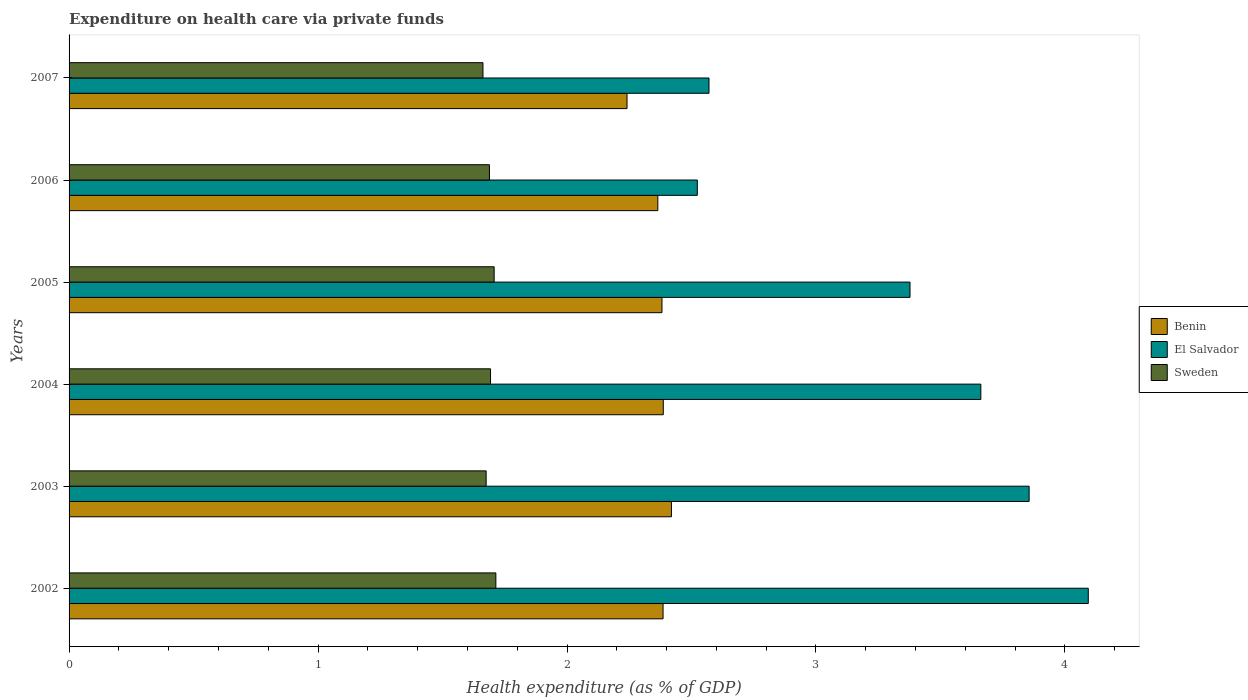How many different coloured bars are there?
Your answer should be very brief. 3. How many groups of bars are there?
Ensure brevity in your answer.  6. Are the number of bars per tick equal to the number of legend labels?
Your response must be concise. Yes. How many bars are there on the 4th tick from the top?
Your answer should be compact. 3. In how many cases, is the number of bars for a given year not equal to the number of legend labels?
Offer a terse response. 0. What is the expenditure made on health care in Sweden in 2005?
Your answer should be very brief. 1.71. Across all years, what is the maximum expenditure made on health care in Sweden?
Offer a very short reply. 1.71. Across all years, what is the minimum expenditure made on health care in Sweden?
Provide a succinct answer. 1.66. What is the total expenditure made on health care in Benin in the graph?
Your answer should be compact. 14.18. What is the difference between the expenditure made on health care in Sweden in 2004 and that in 2006?
Provide a succinct answer. 0. What is the difference between the expenditure made on health care in Benin in 2004 and the expenditure made on health care in Sweden in 2007?
Provide a short and direct response. 0.72. What is the average expenditure made on health care in El Salvador per year?
Make the answer very short. 3.35. In the year 2004, what is the difference between the expenditure made on health care in El Salvador and expenditure made on health care in Benin?
Your answer should be very brief. 1.28. What is the ratio of the expenditure made on health care in Sweden in 2003 to that in 2005?
Make the answer very short. 0.98. Is the difference between the expenditure made on health care in El Salvador in 2006 and 2007 greater than the difference between the expenditure made on health care in Benin in 2006 and 2007?
Keep it short and to the point. No. What is the difference between the highest and the second highest expenditure made on health care in Benin?
Provide a succinct answer. 0.03. What is the difference between the highest and the lowest expenditure made on health care in Sweden?
Your answer should be compact. 0.05. In how many years, is the expenditure made on health care in Benin greater than the average expenditure made on health care in Benin taken over all years?
Give a very brief answer. 5. Is the sum of the expenditure made on health care in Benin in 2002 and 2003 greater than the maximum expenditure made on health care in El Salvador across all years?
Offer a very short reply. Yes. What does the 2nd bar from the top in 2003 represents?
Your answer should be compact. El Salvador. What does the 2nd bar from the bottom in 2005 represents?
Provide a succinct answer. El Salvador. Is it the case that in every year, the sum of the expenditure made on health care in Benin and expenditure made on health care in El Salvador is greater than the expenditure made on health care in Sweden?
Give a very brief answer. Yes. Are the values on the major ticks of X-axis written in scientific E-notation?
Ensure brevity in your answer.  No. Does the graph contain any zero values?
Your answer should be compact. No. What is the title of the graph?
Provide a succinct answer. Expenditure on health care via private funds. Does "Fiji" appear as one of the legend labels in the graph?
Give a very brief answer. No. What is the label or title of the X-axis?
Offer a terse response. Health expenditure (as % of GDP). What is the label or title of the Y-axis?
Your answer should be very brief. Years. What is the Health expenditure (as % of GDP) of Benin in 2002?
Give a very brief answer. 2.39. What is the Health expenditure (as % of GDP) in El Salvador in 2002?
Offer a terse response. 4.09. What is the Health expenditure (as % of GDP) in Sweden in 2002?
Provide a short and direct response. 1.71. What is the Health expenditure (as % of GDP) in Benin in 2003?
Give a very brief answer. 2.42. What is the Health expenditure (as % of GDP) of El Salvador in 2003?
Your answer should be very brief. 3.86. What is the Health expenditure (as % of GDP) in Sweden in 2003?
Give a very brief answer. 1.68. What is the Health expenditure (as % of GDP) in Benin in 2004?
Ensure brevity in your answer.  2.39. What is the Health expenditure (as % of GDP) in El Salvador in 2004?
Your answer should be very brief. 3.66. What is the Health expenditure (as % of GDP) of Sweden in 2004?
Make the answer very short. 1.69. What is the Health expenditure (as % of GDP) of Benin in 2005?
Your response must be concise. 2.38. What is the Health expenditure (as % of GDP) in El Salvador in 2005?
Give a very brief answer. 3.38. What is the Health expenditure (as % of GDP) in Sweden in 2005?
Your answer should be very brief. 1.71. What is the Health expenditure (as % of GDP) in Benin in 2006?
Keep it short and to the point. 2.36. What is the Health expenditure (as % of GDP) of El Salvador in 2006?
Give a very brief answer. 2.52. What is the Health expenditure (as % of GDP) in Sweden in 2006?
Offer a very short reply. 1.69. What is the Health expenditure (as % of GDP) in Benin in 2007?
Your answer should be very brief. 2.24. What is the Health expenditure (as % of GDP) in El Salvador in 2007?
Offer a very short reply. 2.57. What is the Health expenditure (as % of GDP) of Sweden in 2007?
Your answer should be compact. 1.66. Across all years, what is the maximum Health expenditure (as % of GDP) in Benin?
Your answer should be compact. 2.42. Across all years, what is the maximum Health expenditure (as % of GDP) of El Salvador?
Offer a terse response. 4.09. Across all years, what is the maximum Health expenditure (as % of GDP) in Sweden?
Your answer should be very brief. 1.71. Across all years, what is the minimum Health expenditure (as % of GDP) of Benin?
Provide a succinct answer. 2.24. Across all years, what is the minimum Health expenditure (as % of GDP) in El Salvador?
Ensure brevity in your answer.  2.52. Across all years, what is the minimum Health expenditure (as % of GDP) of Sweden?
Give a very brief answer. 1.66. What is the total Health expenditure (as % of GDP) in Benin in the graph?
Ensure brevity in your answer.  14.18. What is the total Health expenditure (as % of GDP) in El Salvador in the graph?
Give a very brief answer. 20.08. What is the total Health expenditure (as % of GDP) in Sweden in the graph?
Offer a very short reply. 10.14. What is the difference between the Health expenditure (as % of GDP) of Benin in 2002 and that in 2003?
Offer a terse response. -0.03. What is the difference between the Health expenditure (as % of GDP) of El Salvador in 2002 and that in 2003?
Provide a succinct answer. 0.24. What is the difference between the Health expenditure (as % of GDP) in Sweden in 2002 and that in 2003?
Give a very brief answer. 0.04. What is the difference between the Health expenditure (as % of GDP) in Benin in 2002 and that in 2004?
Make the answer very short. -0. What is the difference between the Health expenditure (as % of GDP) in El Salvador in 2002 and that in 2004?
Provide a succinct answer. 0.43. What is the difference between the Health expenditure (as % of GDP) in Sweden in 2002 and that in 2004?
Provide a short and direct response. 0.02. What is the difference between the Health expenditure (as % of GDP) in Benin in 2002 and that in 2005?
Provide a short and direct response. 0. What is the difference between the Health expenditure (as % of GDP) in El Salvador in 2002 and that in 2005?
Make the answer very short. 0.72. What is the difference between the Health expenditure (as % of GDP) of Sweden in 2002 and that in 2005?
Make the answer very short. 0.01. What is the difference between the Health expenditure (as % of GDP) in Benin in 2002 and that in 2006?
Keep it short and to the point. 0.02. What is the difference between the Health expenditure (as % of GDP) in El Salvador in 2002 and that in 2006?
Your answer should be very brief. 1.57. What is the difference between the Health expenditure (as % of GDP) of Sweden in 2002 and that in 2006?
Make the answer very short. 0.03. What is the difference between the Health expenditure (as % of GDP) of Benin in 2002 and that in 2007?
Make the answer very short. 0.14. What is the difference between the Health expenditure (as % of GDP) of El Salvador in 2002 and that in 2007?
Offer a very short reply. 1.52. What is the difference between the Health expenditure (as % of GDP) of Sweden in 2002 and that in 2007?
Your answer should be compact. 0.05. What is the difference between the Health expenditure (as % of GDP) of Benin in 2003 and that in 2004?
Your response must be concise. 0.03. What is the difference between the Health expenditure (as % of GDP) of El Salvador in 2003 and that in 2004?
Ensure brevity in your answer.  0.19. What is the difference between the Health expenditure (as % of GDP) of Sweden in 2003 and that in 2004?
Give a very brief answer. -0.02. What is the difference between the Health expenditure (as % of GDP) in Benin in 2003 and that in 2005?
Keep it short and to the point. 0.04. What is the difference between the Health expenditure (as % of GDP) of El Salvador in 2003 and that in 2005?
Offer a very short reply. 0.48. What is the difference between the Health expenditure (as % of GDP) of Sweden in 2003 and that in 2005?
Ensure brevity in your answer.  -0.03. What is the difference between the Health expenditure (as % of GDP) in Benin in 2003 and that in 2006?
Offer a terse response. 0.05. What is the difference between the Health expenditure (as % of GDP) of El Salvador in 2003 and that in 2006?
Your answer should be compact. 1.33. What is the difference between the Health expenditure (as % of GDP) of Sweden in 2003 and that in 2006?
Provide a short and direct response. -0.01. What is the difference between the Health expenditure (as % of GDP) of Benin in 2003 and that in 2007?
Provide a succinct answer. 0.18. What is the difference between the Health expenditure (as % of GDP) of El Salvador in 2003 and that in 2007?
Give a very brief answer. 1.29. What is the difference between the Health expenditure (as % of GDP) in Sweden in 2003 and that in 2007?
Ensure brevity in your answer.  0.01. What is the difference between the Health expenditure (as % of GDP) in Benin in 2004 and that in 2005?
Provide a succinct answer. 0.01. What is the difference between the Health expenditure (as % of GDP) in El Salvador in 2004 and that in 2005?
Ensure brevity in your answer.  0.28. What is the difference between the Health expenditure (as % of GDP) in Sweden in 2004 and that in 2005?
Ensure brevity in your answer.  -0.01. What is the difference between the Health expenditure (as % of GDP) in Benin in 2004 and that in 2006?
Ensure brevity in your answer.  0.02. What is the difference between the Health expenditure (as % of GDP) in El Salvador in 2004 and that in 2006?
Provide a short and direct response. 1.14. What is the difference between the Health expenditure (as % of GDP) in Sweden in 2004 and that in 2006?
Provide a succinct answer. 0. What is the difference between the Health expenditure (as % of GDP) of Benin in 2004 and that in 2007?
Ensure brevity in your answer.  0.15. What is the difference between the Health expenditure (as % of GDP) in El Salvador in 2004 and that in 2007?
Your response must be concise. 1.09. What is the difference between the Health expenditure (as % of GDP) in Sweden in 2004 and that in 2007?
Ensure brevity in your answer.  0.03. What is the difference between the Health expenditure (as % of GDP) of Benin in 2005 and that in 2006?
Provide a succinct answer. 0.02. What is the difference between the Health expenditure (as % of GDP) of El Salvador in 2005 and that in 2006?
Provide a short and direct response. 0.85. What is the difference between the Health expenditure (as % of GDP) of Sweden in 2005 and that in 2006?
Ensure brevity in your answer.  0.02. What is the difference between the Health expenditure (as % of GDP) in Benin in 2005 and that in 2007?
Provide a short and direct response. 0.14. What is the difference between the Health expenditure (as % of GDP) in El Salvador in 2005 and that in 2007?
Your response must be concise. 0.81. What is the difference between the Health expenditure (as % of GDP) of Sweden in 2005 and that in 2007?
Provide a succinct answer. 0.04. What is the difference between the Health expenditure (as % of GDP) of Benin in 2006 and that in 2007?
Provide a short and direct response. 0.12. What is the difference between the Health expenditure (as % of GDP) of El Salvador in 2006 and that in 2007?
Ensure brevity in your answer.  -0.05. What is the difference between the Health expenditure (as % of GDP) in Sweden in 2006 and that in 2007?
Offer a very short reply. 0.03. What is the difference between the Health expenditure (as % of GDP) of Benin in 2002 and the Health expenditure (as % of GDP) of El Salvador in 2003?
Your answer should be very brief. -1.47. What is the difference between the Health expenditure (as % of GDP) in Benin in 2002 and the Health expenditure (as % of GDP) in Sweden in 2003?
Your response must be concise. 0.71. What is the difference between the Health expenditure (as % of GDP) of El Salvador in 2002 and the Health expenditure (as % of GDP) of Sweden in 2003?
Your response must be concise. 2.42. What is the difference between the Health expenditure (as % of GDP) of Benin in 2002 and the Health expenditure (as % of GDP) of El Salvador in 2004?
Keep it short and to the point. -1.28. What is the difference between the Health expenditure (as % of GDP) of Benin in 2002 and the Health expenditure (as % of GDP) of Sweden in 2004?
Provide a succinct answer. 0.69. What is the difference between the Health expenditure (as % of GDP) in El Salvador in 2002 and the Health expenditure (as % of GDP) in Sweden in 2004?
Your response must be concise. 2.4. What is the difference between the Health expenditure (as % of GDP) in Benin in 2002 and the Health expenditure (as % of GDP) in El Salvador in 2005?
Make the answer very short. -0.99. What is the difference between the Health expenditure (as % of GDP) in Benin in 2002 and the Health expenditure (as % of GDP) in Sweden in 2005?
Your answer should be compact. 0.68. What is the difference between the Health expenditure (as % of GDP) of El Salvador in 2002 and the Health expenditure (as % of GDP) of Sweden in 2005?
Provide a short and direct response. 2.39. What is the difference between the Health expenditure (as % of GDP) of Benin in 2002 and the Health expenditure (as % of GDP) of El Salvador in 2006?
Ensure brevity in your answer.  -0.14. What is the difference between the Health expenditure (as % of GDP) in Benin in 2002 and the Health expenditure (as % of GDP) in Sweden in 2006?
Keep it short and to the point. 0.7. What is the difference between the Health expenditure (as % of GDP) of El Salvador in 2002 and the Health expenditure (as % of GDP) of Sweden in 2006?
Your answer should be very brief. 2.41. What is the difference between the Health expenditure (as % of GDP) of Benin in 2002 and the Health expenditure (as % of GDP) of El Salvador in 2007?
Provide a succinct answer. -0.18. What is the difference between the Health expenditure (as % of GDP) in Benin in 2002 and the Health expenditure (as % of GDP) in Sweden in 2007?
Provide a succinct answer. 0.72. What is the difference between the Health expenditure (as % of GDP) of El Salvador in 2002 and the Health expenditure (as % of GDP) of Sweden in 2007?
Offer a terse response. 2.43. What is the difference between the Health expenditure (as % of GDP) in Benin in 2003 and the Health expenditure (as % of GDP) in El Salvador in 2004?
Offer a terse response. -1.24. What is the difference between the Health expenditure (as % of GDP) in Benin in 2003 and the Health expenditure (as % of GDP) in Sweden in 2004?
Provide a short and direct response. 0.73. What is the difference between the Health expenditure (as % of GDP) of El Salvador in 2003 and the Health expenditure (as % of GDP) of Sweden in 2004?
Give a very brief answer. 2.16. What is the difference between the Health expenditure (as % of GDP) of Benin in 2003 and the Health expenditure (as % of GDP) of El Salvador in 2005?
Make the answer very short. -0.96. What is the difference between the Health expenditure (as % of GDP) of Benin in 2003 and the Health expenditure (as % of GDP) of Sweden in 2005?
Your answer should be compact. 0.71. What is the difference between the Health expenditure (as % of GDP) in El Salvador in 2003 and the Health expenditure (as % of GDP) in Sweden in 2005?
Give a very brief answer. 2.15. What is the difference between the Health expenditure (as % of GDP) of Benin in 2003 and the Health expenditure (as % of GDP) of El Salvador in 2006?
Your answer should be very brief. -0.1. What is the difference between the Health expenditure (as % of GDP) of Benin in 2003 and the Health expenditure (as % of GDP) of Sweden in 2006?
Your answer should be very brief. 0.73. What is the difference between the Health expenditure (as % of GDP) of El Salvador in 2003 and the Health expenditure (as % of GDP) of Sweden in 2006?
Give a very brief answer. 2.17. What is the difference between the Health expenditure (as % of GDP) in Benin in 2003 and the Health expenditure (as % of GDP) in El Salvador in 2007?
Ensure brevity in your answer.  -0.15. What is the difference between the Health expenditure (as % of GDP) in Benin in 2003 and the Health expenditure (as % of GDP) in Sweden in 2007?
Your answer should be very brief. 0.76. What is the difference between the Health expenditure (as % of GDP) of El Salvador in 2003 and the Health expenditure (as % of GDP) of Sweden in 2007?
Your response must be concise. 2.19. What is the difference between the Health expenditure (as % of GDP) in Benin in 2004 and the Health expenditure (as % of GDP) in El Salvador in 2005?
Offer a very short reply. -0.99. What is the difference between the Health expenditure (as % of GDP) in Benin in 2004 and the Health expenditure (as % of GDP) in Sweden in 2005?
Your answer should be very brief. 0.68. What is the difference between the Health expenditure (as % of GDP) in El Salvador in 2004 and the Health expenditure (as % of GDP) in Sweden in 2005?
Provide a short and direct response. 1.95. What is the difference between the Health expenditure (as % of GDP) in Benin in 2004 and the Health expenditure (as % of GDP) in El Salvador in 2006?
Your answer should be very brief. -0.14. What is the difference between the Health expenditure (as % of GDP) in Benin in 2004 and the Health expenditure (as % of GDP) in Sweden in 2006?
Your answer should be compact. 0.7. What is the difference between the Health expenditure (as % of GDP) in El Salvador in 2004 and the Health expenditure (as % of GDP) in Sweden in 2006?
Your answer should be very brief. 1.97. What is the difference between the Health expenditure (as % of GDP) in Benin in 2004 and the Health expenditure (as % of GDP) in El Salvador in 2007?
Your answer should be compact. -0.18. What is the difference between the Health expenditure (as % of GDP) of Benin in 2004 and the Health expenditure (as % of GDP) of Sweden in 2007?
Offer a very short reply. 0.72. What is the difference between the Health expenditure (as % of GDP) in El Salvador in 2004 and the Health expenditure (as % of GDP) in Sweden in 2007?
Your answer should be compact. 2. What is the difference between the Health expenditure (as % of GDP) in Benin in 2005 and the Health expenditure (as % of GDP) in El Salvador in 2006?
Provide a succinct answer. -0.14. What is the difference between the Health expenditure (as % of GDP) in Benin in 2005 and the Health expenditure (as % of GDP) in Sweden in 2006?
Your answer should be very brief. 0.69. What is the difference between the Health expenditure (as % of GDP) in El Salvador in 2005 and the Health expenditure (as % of GDP) in Sweden in 2006?
Your answer should be very brief. 1.69. What is the difference between the Health expenditure (as % of GDP) of Benin in 2005 and the Health expenditure (as % of GDP) of El Salvador in 2007?
Keep it short and to the point. -0.19. What is the difference between the Health expenditure (as % of GDP) of Benin in 2005 and the Health expenditure (as % of GDP) of Sweden in 2007?
Keep it short and to the point. 0.72. What is the difference between the Health expenditure (as % of GDP) in El Salvador in 2005 and the Health expenditure (as % of GDP) in Sweden in 2007?
Your answer should be compact. 1.72. What is the difference between the Health expenditure (as % of GDP) in Benin in 2006 and the Health expenditure (as % of GDP) in El Salvador in 2007?
Offer a terse response. -0.21. What is the difference between the Health expenditure (as % of GDP) in Benin in 2006 and the Health expenditure (as % of GDP) in Sweden in 2007?
Ensure brevity in your answer.  0.7. What is the difference between the Health expenditure (as % of GDP) in El Salvador in 2006 and the Health expenditure (as % of GDP) in Sweden in 2007?
Your response must be concise. 0.86. What is the average Health expenditure (as % of GDP) in Benin per year?
Give a very brief answer. 2.36. What is the average Health expenditure (as % of GDP) of El Salvador per year?
Provide a succinct answer. 3.35. What is the average Health expenditure (as % of GDP) of Sweden per year?
Keep it short and to the point. 1.69. In the year 2002, what is the difference between the Health expenditure (as % of GDP) of Benin and Health expenditure (as % of GDP) of El Salvador?
Your response must be concise. -1.71. In the year 2002, what is the difference between the Health expenditure (as % of GDP) of Benin and Health expenditure (as % of GDP) of Sweden?
Your answer should be compact. 0.67. In the year 2002, what is the difference between the Health expenditure (as % of GDP) of El Salvador and Health expenditure (as % of GDP) of Sweden?
Make the answer very short. 2.38. In the year 2003, what is the difference between the Health expenditure (as % of GDP) of Benin and Health expenditure (as % of GDP) of El Salvador?
Your response must be concise. -1.44. In the year 2003, what is the difference between the Health expenditure (as % of GDP) of Benin and Health expenditure (as % of GDP) of Sweden?
Give a very brief answer. 0.74. In the year 2003, what is the difference between the Health expenditure (as % of GDP) of El Salvador and Health expenditure (as % of GDP) of Sweden?
Make the answer very short. 2.18. In the year 2004, what is the difference between the Health expenditure (as % of GDP) of Benin and Health expenditure (as % of GDP) of El Salvador?
Give a very brief answer. -1.28. In the year 2004, what is the difference between the Health expenditure (as % of GDP) in Benin and Health expenditure (as % of GDP) in Sweden?
Give a very brief answer. 0.69. In the year 2004, what is the difference between the Health expenditure (as % of GDP) of El Salvador and Health expenditure (as % of GDP) of Sweden?
Make the answer very short. 1.97. In the year 2005, what is the difference between the Health expenditure (as % of GDP) of Benin and Health expenditure (as % of GDP) of El Salvador?
Ensure brevity in your answer.  -1. In the year 2005, what is the difference between the Health expenditure (as % of GDP) in Benin and Health expenditure (as % of GDP) in Sweden?
Provide a succinct answer. 0.67. In the year 2005, what is the difference between the Health expenditure (as % of GDP) in El Salvador and Health expenditure (as % of GDP) in Sweden?
Keep it short and to the point. 1.67. In the year 2006, what is the difference between the Health expenditure (as % of GDP) of Benin and Health expenditure (as % of GDP) of El Salvador?
Your answer should be very brief. -0.16. In the year 2006, what is the difference between the Health expenditure (as % of GDP) in Benin and Health expenditure (as % of GDP) in Sweden?
Offer a very short reply. 0.68. In the year 2006, what is the difference between the Health expenditure (as % of GDP) of El Salvador and Health expenditure (as % of GDP) of Sweden?
Offer a terse response. 0.83. In the year 2007, what is the difference between the Health expenditure (as % of GDP) of Benin and Health expenditure (as % of GDP) of El Salvador?
Provide a succinct answer. -0.33. In the year 2007, what is the difference between the Health expenditure (as % of GDP) in Benin and Health expenditure (as % of GDP) in Sweden?
Your answer should be very brief. 0.58. In the year 2007, what is the difference between the Health expenditure (as % of GDP) in El Salvador and Health expenditure (as % of GDP) in Sweden?
Offer a terse response. 0.91. What is the ratio of the Health expenditure (as % of GDP) of Benin in 2002 to that in 2003?
Provide a short and direct response. 0.99. What is the ratio of the Health expenditure (as % of GDP) of El Salvador in 2002 to that in 2003?
Offer a terse response. 1.06. What is the ratio of the Health expenditure (as % of GDP) in Sweden in 2002 to that in 2003?
Provide a short and direct response. 1.02. What is the ratio of the Health expenditure (as % of GDP) of Benin in 2002 to that in 2004?
Your response must be concise. 1. What is the ratio of the Health expenditure (as % of GDP) in El Salvador in 2002 to that in 2004?
Offer a very short reply. 1.12. What is the ratio of the Health expenditure (as % of GDP) in Sweden in 2002 to that in 2004?
Offer a very short reply. 1.01. What is the ratio of the Health expenditure (as % of GDP) of Benin in 2002 to that in 2005?
Keep it short and to the point. 1. What is the ratio of the Health expenditure (as % of GDP) of El Salvador in 2002 to that in 2005?
Provide a short and direct response. 1.21. What is the ratio of the Health expenditure (as % of GDP) in Sweden in 2002 to that in 2005?
Provide a short and direct response. 1. What is the ratio of the Health expenditure (as % of GDP) of Benin in 2002 to that in 2006?
Your answer should be very brief. 1.01. What is the ratio of the Health expenditure (as % of GDP) of El Salvador in 2002 to that in 2006?
Provide a succinct answer. 1.62. What is the ratio of the Health expenditure (as % of GDP) of Sweden in 2002 to that in 2006?
Your response must be concise. 1.02. What is the ratio of the Health expenditure (as % of GDP) in Benin in 2002 to that in 2007?
Keep it short and to the point. 1.06. What is the ratio of the Health expenditure (as % of GDP) of El Salvador in 2002 to that in 2007?
Offer a terse response. 1.59. What is the ratio of the Health expenditure (as % of GDP) in Sweden in 2002 to that in 2007?
Offer a very short reply. 1.03. What is the ratio of the Health expenditure (as % of GDP) in Benin in 2003 to that in 2004?
Keep it short and to the point. 1.01. What is the ratio of the Health expenditure (as % of GDP) in El Salvador in 2003 to that in 2004?
Provide a short and direct response. 1.05. What is the ratio of the Health expenditure (as % of GDP) in El Salvador in 2003 to that in 2005?
Give a very brief answer. 1.14. What is the ratio of the Health expenditure (as % of GDP) in Sweden in 2003 to that in 2005?
Provide a succinct answer. 0.98. What is the ratio of the Health expenditure (as % of GDP) of Benin in 2003 to that in 2006?
Make the answer very short. 1.02. What is the ratio of the Health expenditure (as % of GDP) of El Salvador in 2003 to that in 2006?
Your answer should be compact. 1.53. What is the ratio of the Health expenditure (as % of GDP) in Sweden in 2003 to that in 2006?
Your answer should be very brief. 0.99. What is the ratio of the Health expenditure (as % of GDP) of Benin in 2003 to that in 2007?
Offer a very short reply. 1.08. What is the ratio of the Health expenditure (as % of GDP) of El Salvador in 2003 to that in 2007?
Keep it short and to the point. 1.5. What is the ratio of the Health expenditure (as % of GDP) in Sweden in 2003 to that in 2007?
Offer a very short reply. 1.01. What is the ratio of the Health expenditure (as % of GDP) of Benin in 2004 to that in 2005?
Make the answer very short. 1. What is the ratio of the Health expenditure (as % of GDP) in El Salvador in 2004 to that in 2005?
Your answer should be compact. 1.08. What is the ratio of the Health expenditure (as % of GDP) in Benin in 2004 to that in 2006?
Your answer should be very brief. 1.01. What is the ratio of the Health expenditure (as % of GDP) in El Salvador in 2004 to that in 2006?
Offer a very short reply. 1.45. What is the ratio of the Health expenditure (as % of GDP) in Sweden in 2004 to that in 2006?
Provide a succinct answer. 1. What is the ratio of the Health expenditure (as % of GDP) of Benin in 2004 to that in 2007?
Your answer should be very brief. 1.06. What is the ratio of the Health expenditure (as % of GDP) in El Salvador in 2004 to that in 2007?
Your answer should be compact. 1.42. What is the ratio of the Health expenditure (as % of GDP) of Sweden in 2004 to that in 2007?
Provide a succinct answer. 1.02. What is the ratio of the Health expenditure (as % of GDP) in Benin in 2005 to that in 2006?
Provide a short and direct response. 1.01. What is the ratio of the Health expenditure (as % of GDP) in El Salvador in 2005 to that in 2006?
Offer a very short reply. 1.34. What is the ratio of the Health expenditure (as % of GDP) of Sweden in 2005 to that in 2006?
Offer a terse response. 1.01. What is the ratio of the Health expenditure (as % of GDP) in Benin in 2005 to that in 2007?
Offer a very short reply. 1.06. What is the ratio of the Health expenditure (as % of GDP) of El Salvador in 2005 to that in 2007?
Provide a short and direct response. 1.31. What is the ratio of the Health expenditure (as % of GDP) of Benin in 2006 to that in 2007?
Keep it short and to the point. 1.06. What is the ratio of the Health expenditure (as % of GDP) of El Salvador in 2006 to that in 2007?
Offer a very short reply. 0.98. What is the ratio of the Health expenditure (as % of GDP) of Sweden in 2006 to that in 2007?
Keep it short and to the point. 1.02. What is the difference between the highest and the second highest Health expenditure (as % of GDP) of Benin?
Provide a short and direct response. 0.03. What is the difference between the highest and the second highest Health expenditure (as % of GDP) in El Salvador?
Provide a succinct answer. 0.24. What is the difference between the highest and the second highest Health expenditure (as % of GDP) of Sweden?
Your response must be concise. 0.01. What is the difference between the highest and the lowest Health expenditure (as % of GDP) in Benin?
Provide a short and direct response. 0.18. What is the difference between the highest and the lowest Health expenditure (as % of GDP) of El Salvador?
Offer a terse response. 1.57. What is the difference between the highest and the lowest Health expenditure (as % of GDP) in Sweden?
Your answer should be compact. 0.05. 